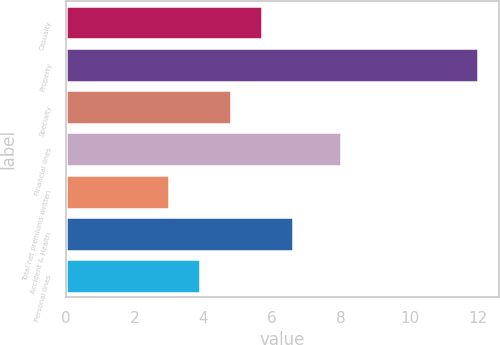Convert chart. <chart><loc_0><loc_0><loc_500><loc_500><bar_chart><fcel>Casualty<fcel>Property<fcel>Specialty<fcel>Financial lines<fcel>Total net premiums written<fcel>Accident & Health<fcel>Personal lines<nl><fcel>5.7<fcel>12<fcel>4.8<fcel>8<fcel>3<fcel>6.6<fcel>3.9<nl></chart> 